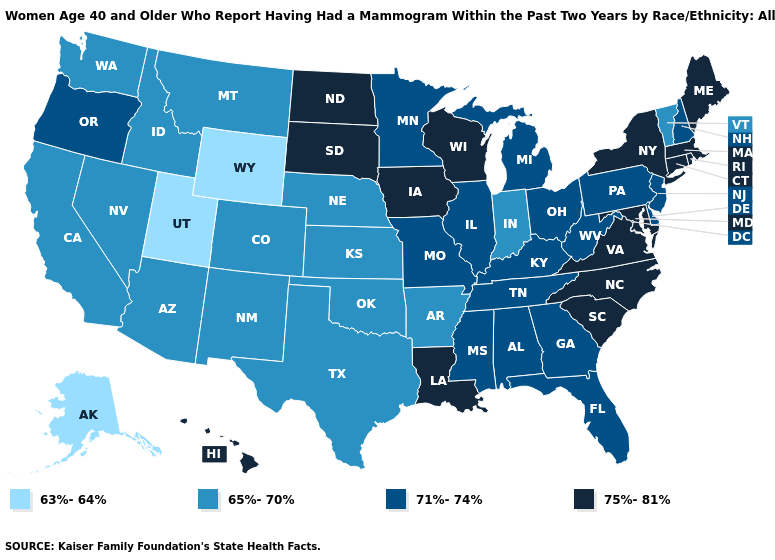What is the value of Hawaii?
Keep it brief. 75%-81%. Does North Carolina have the highest value in the South?
Be succinct. Yes. What is the value of Rhode Island?
Write a very short answer. 75%-81%. Name the states that have a value in the range 75%-81%?
Write a very short answer. Connecticut, Hawaii, Iowa, Louisiana, Maine, Maryland, Massachusetts, New York, North Carolina, North Dakota, Rhode Island, South Carolina, South Dakota, Virginia, Wisconsin. What is the value of Florida?
Concise answer only. 71%-74%. Does Utah have the lowest value in the USA?
Be succinct. Yes. Name the states that have a value in the range 63%-64%?
Be succinct. Alaska, Utah, Wyoming. Does the first symbol in the legend represent the smallest category?
Short answer required. Yes. What is the lowest value in the South?
Be succinct. 65%-70%. Does the map have missing data?
Answer briefly. No. Among the states that border Vermont , does New Hampshire have the highest value?
Write a very short answer. No. Name the states that have a value in the range 65%-70%?
Answer briefly. Arizona, Arkansas, California, Colorado, Idaho, Indiana, Kansas, Montana, Nebraska, Nevada, New Mexico, Oklahoma, Texas, Vermont, Washington. Does the first symbol in the legend represent the smallest category?
Concise answer only. Yes. Does Iowa have the same value as Vermont?
Answer briefly. No. Name the states that have a value in the range 63%-64%?
Keep it brief. Alaska, Utah, Wyoming. 